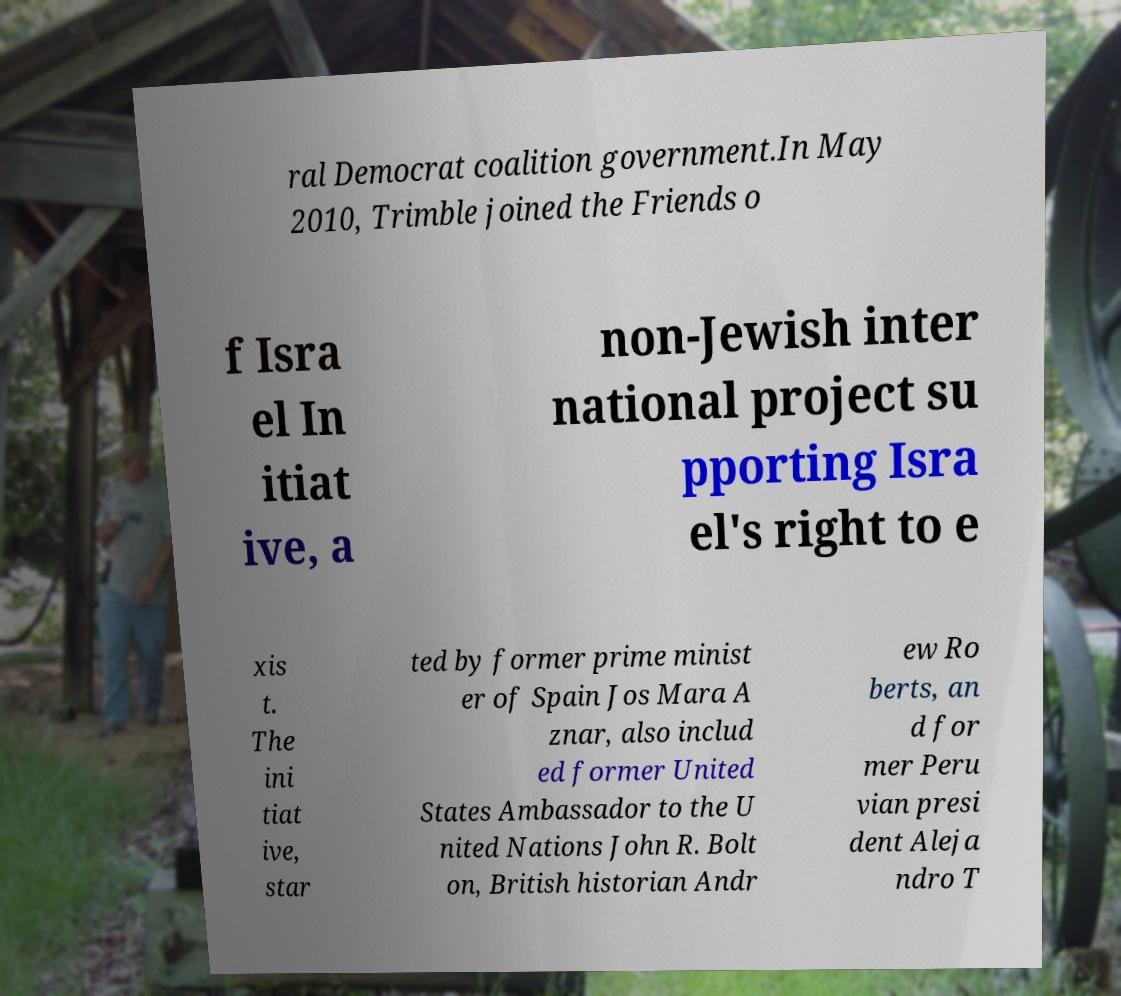For documentation purposes, I need the text within this image transcribed. Could you provide that? ral Democrat coalition government.In May 2010, Trimble joined the Friends o f Isra el In itiat ive, a non-Jewish inter national project su pporting Isra el's right to e xis t. The ini tiat ive, star ted by former prime minist er of Spain Jos Mara A znar, also includ ed former United States Ambassador to the U nited Nations John R. Bolt on, British historian Andr ew Ro berts, an d for mer Peru vian presi dent Aleja ndro T 